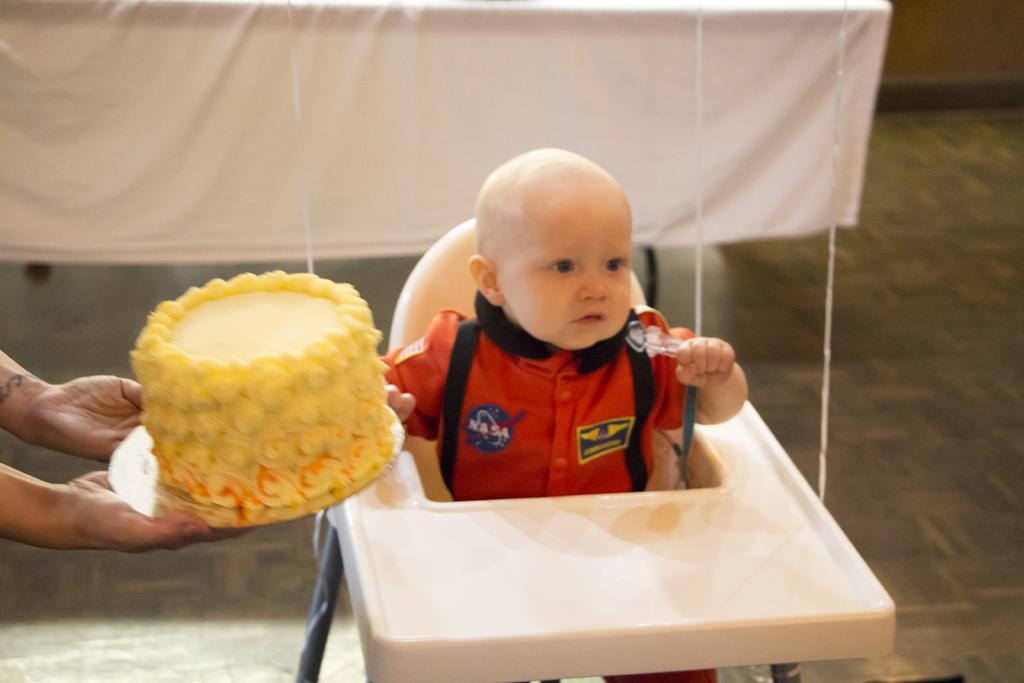In one or two sentences, can you explain what this image depicts? In this picture we can see a person holding a cake in the hands on the left side. There is a baby sitting on a chair. We can see a white cloth in the background. 